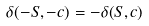Convert formula to latex. <formula><loc_0><loc_0><loc_500><loc_500>\delta ( - S , - c ) = - \delta ( S , c )</formula> 